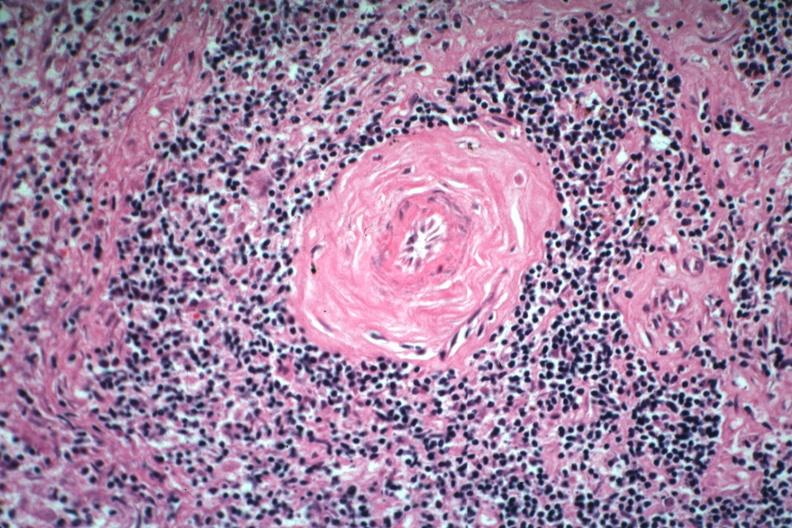s spleen present?
Answer the question using a single word or phrase. Yes 